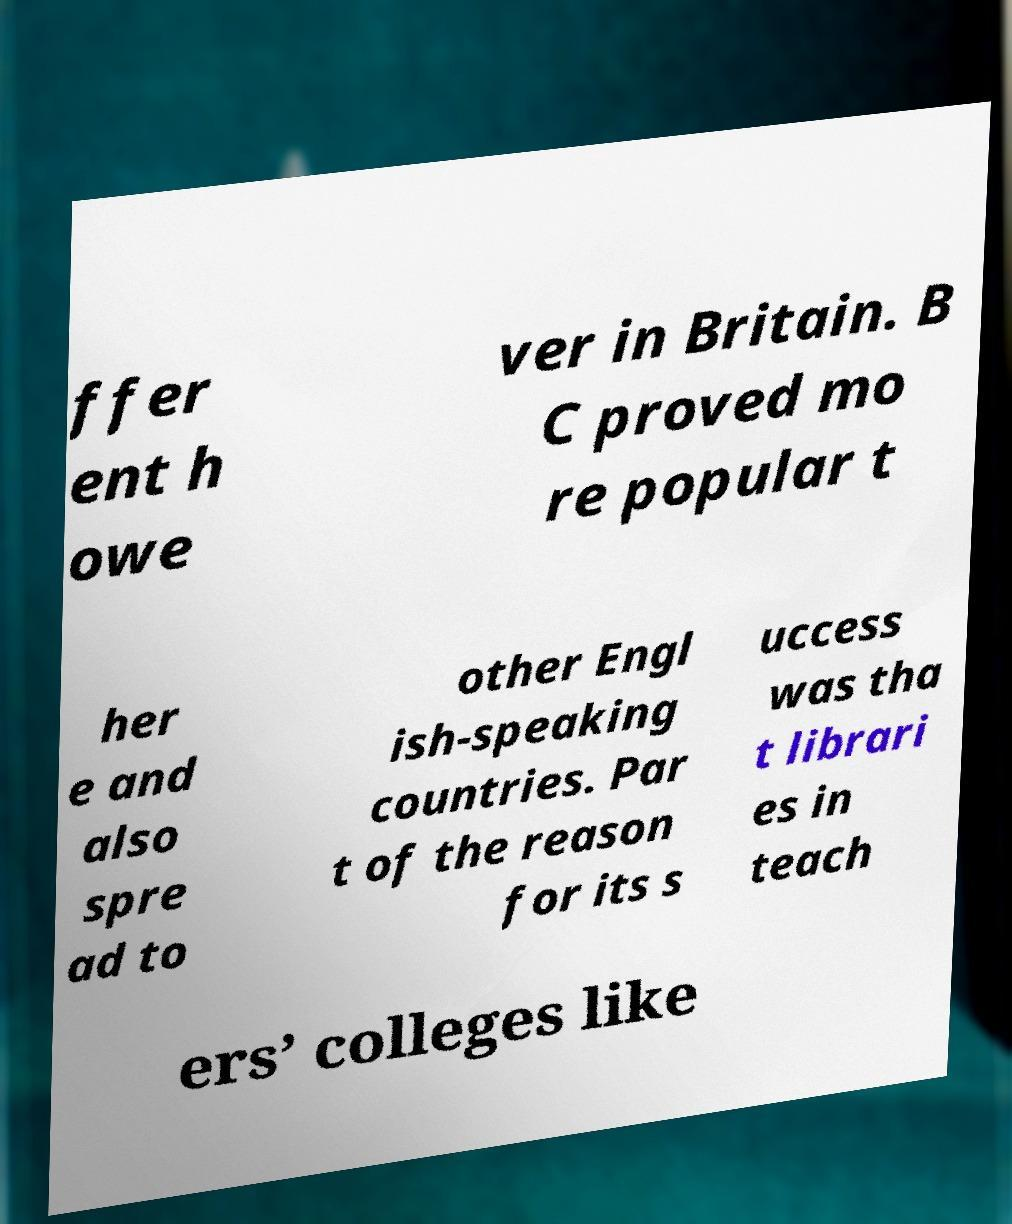Could you assist in decoding the text presented in this image and type it out clearly? ffer ent h owe ver in Britain. B C proved mo re popular t her e and also spre ad to other Engl ish-speaking countries. Par t of the reason for its s uccess was tha t librari es in teach ers’ colleges like 